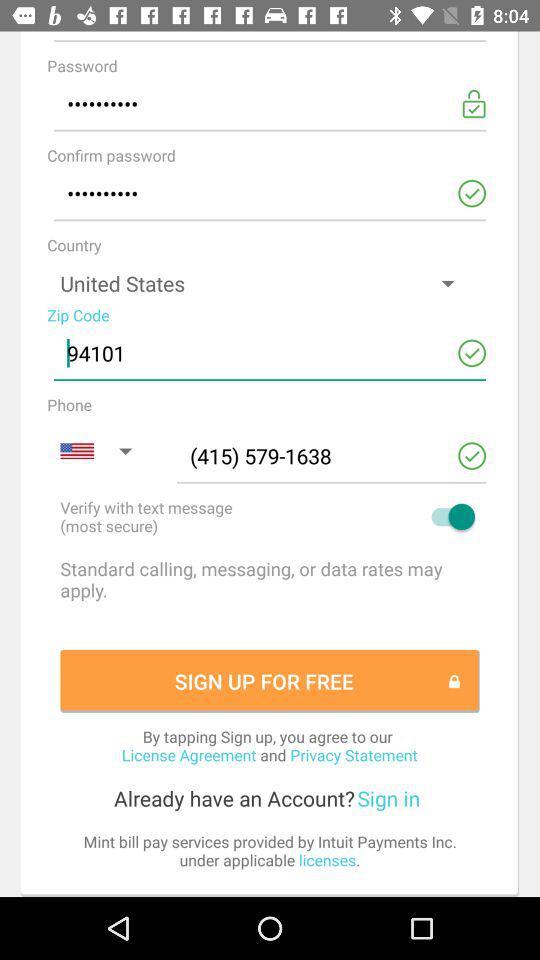Which company provides the "Mint bill pay" services? "Mint bill pay" services are provided by "Intuit Payments Inc". 